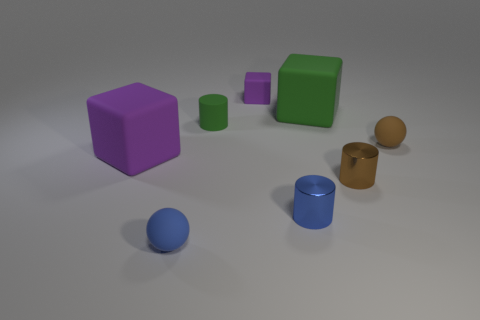How many other things are the same size as the blue sphere?
Your answer should be compact. 5. What size is the rubber block that is the same color as the small matte cylinder?
Provide a short and direct response. Large. Do the purple matte object that is in front of the green cylinder and the small purple object have the same shape?
Ensure brevity in your answer.  Yes. How many other things are the same shape as the tiny brown rubber thing?
Provide a short and direct response. 1. There is a big thing behind the large purple object; what shape is it?
Your answer should be very brief. Cube. Is there a brown object made of the same material as the large green thing?
Your response must be concise. Yes. There is a block that is in front of the green block; is its color the same as the small matte block?
Ensure brevity in your answer.  Yes. How big is the green rubber block?
Give a very brief answer. Large. There is a purple object right of the green matte thing that is in front of the large green object; are there any matte objects behind it?
Offer a terse response. No. How many brown shiny cylinders are behind the tiny green cylinder?
Your answer should be very brief. 0. 